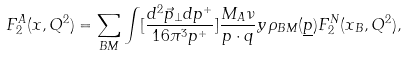<formula> <loc_0><loc_0><loc_500><loc_500>F _ { 2 } ^ { A } ( x , Q ^ { 2 } ) = \sum _ { B M } \int [ \frac { d ^ { 2 } \vec { p } _ { \perp } d p ^ { + } } { 1 6 \pi ^ { 3 } p ^ { + } } ] \frac { M _ { A } \nu } { p \cdot q } y \, \rho _ { B M } ( \underline { p } ) F _ { 2 } ^ { N } ( x _ { B } , Q ^ { 2 } ) ,</formula> 